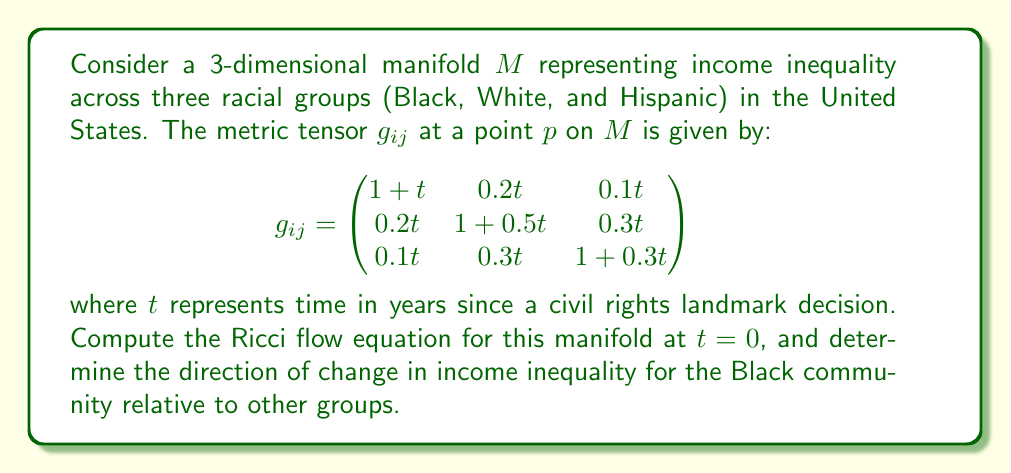Solve this math problem. To solve this problem, we need to follow these steps:

1) The Ricci flow equation is given by:

   $$\frac{\partial g_{ij}}{\partial t} = -2R_{ij}$$

   where $R_{ij}$ is the Ricci curvature tensor.

2) To find $R_{ij}$, we first need to calculate the Christoffel symbols $\Gamma^k_{ij}$:

   $$\Gamma^k_{ij} = \frac{1}{2}g^{kl}(\partial_i g_{jl} + \partial_j g_{il} - \partial_l g_{ij})$$

3) At $t = 0$, the metric tensor simplifies to:

   $$g_{ij} = \begin{pmatrix}
   1 & 0 & 0 \\
   0 & 1 & 0 \\
   0 & 0 & 1
   \end{pmatrix}$$

4) The inverse metric $g^{ij}$ is the same as $g_{ij}$ at $t = 0$.

5) Calculating the partial derivatives of $g_{ij}$ with respect to $t$:

   $$\frac{\partial g_{ij}}{\partial t} = \begin{pmatrix}
   1 & 0.2 & 0.1 \\
   0.2 & 0.5 & 0.3 \\
   0.1 & 0.3 & 0.3
   \end{pmatrix}$$

6) At $t = 0$, all Christoffel symbols vanish because all partial derivatives with respect to spatial coordinates are zero.

7) The Ricci tensor $R_{ij}$ is then equal to the negative half of the partial derivative of $g_{ij}$ with respect to $t$:

   $$R_{ij} = -\frac{1}{2}\frac{\partial g_{ij}}{\partial t} = \begin{pmatrix}
   -0.5 & -0.1 & -0.05 \\
   -0.1 & -0.25 & -0.15 \\
   -0.05 & -0.15 & -0.15
   \end{pmatrix}$$

8) The Ricci flow equation at $t = 0$ is therefore:

   $$\frac{\partial g_{ij}}{\partial t} = \begin{pmatrix}
   1 & 0.2 & 0.1 \\
   0.2 & 0.5 & 0.3 \\
   0.1 & 0.3 & 0.3
   \end{pmatrix}$$

9) To determine the direction of change in income inequality for the Black community, we focus on the first row/column of the Ricci flow equation. The diagonal term (1) is larger than the off-diagonal terms (0.2 and 0.1), indicating that the metric is expanding faster in the Black dimension compared to its relationship with other groups.
Answer: The Ricci flow equation at $t = 0$ is:

$$\frac{\partial g_{ij}}{\partial t} = \begin{pmatrix}
1 & 0.2 & 0.1 \\
0.2 & 0.5 & 0.3 \\
0.1 & 0.3 & 0.3
\end{pmatrix}$$

The direction of change in income inequality for the Black community is towards increased inequality relative to other groups, as indicated by the larger diagonal term (1) compared to off-diagonal terms (0.2 and 0.1) in the first row/column of the Ricci flow equation. 